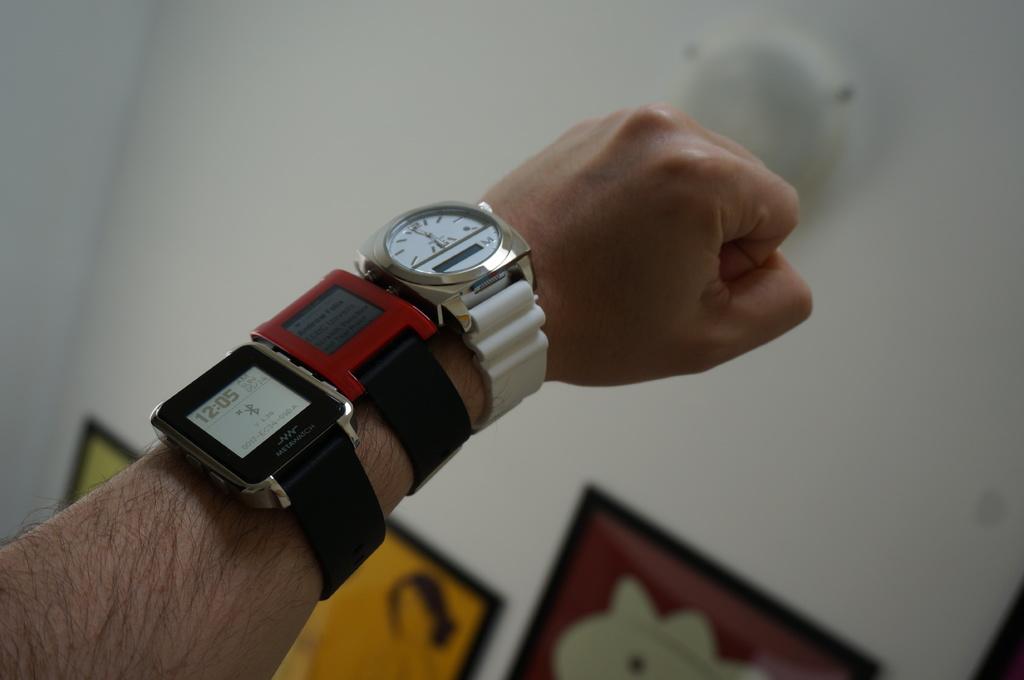What time is it on the black watch?
Your response must be concise. 12:05. Count the timepieces?
Ensure brevity in your answer.  3. 